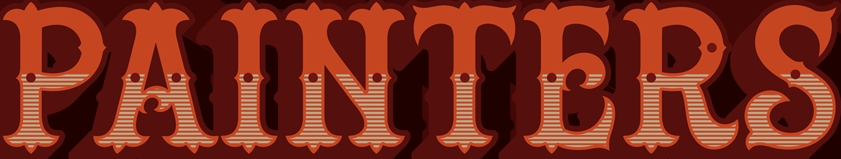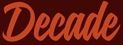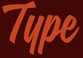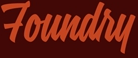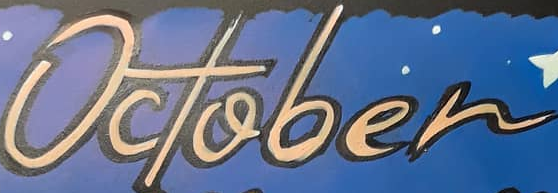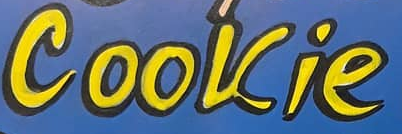What words can you see in these images in sequence, separated by a semicolon? PAINTERS; Decade; Type; Foundry; October; Cookie 